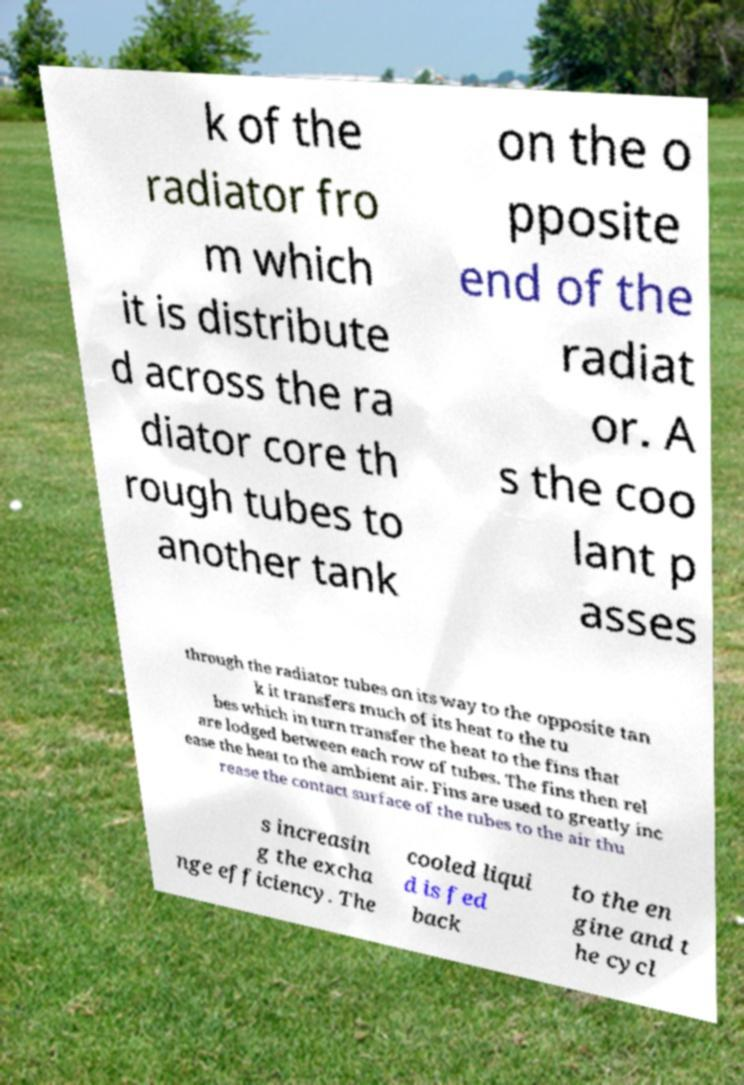I need the written content from this picture converted into text. Can you do that? k of the radiator fro m which it is distribute d across the ra diator core th rough tubes to another tank on the o pposite end of the radiat or. A s the coo lant p asses through the radiator tubes on its way to the opposite tan k it transfers much of its heat to the tu bes which in turn transfer the heat to the fins that are lodged between each row of tubes. The fins then rel ease the heat to the ambient air. Fins are used to greatly inc rease the contact surface of the tubes to the air thu s increasin g the excha nge efficiency. The cooled liqui d is fed back to the en gine and t he cycl 